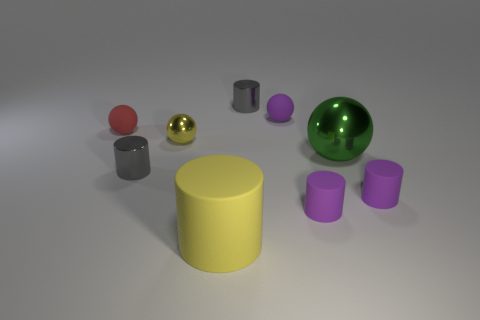The gray cylinder on the left side of the cylinder that is behind the matte ball that is behind the small red object is made of what material? metal 